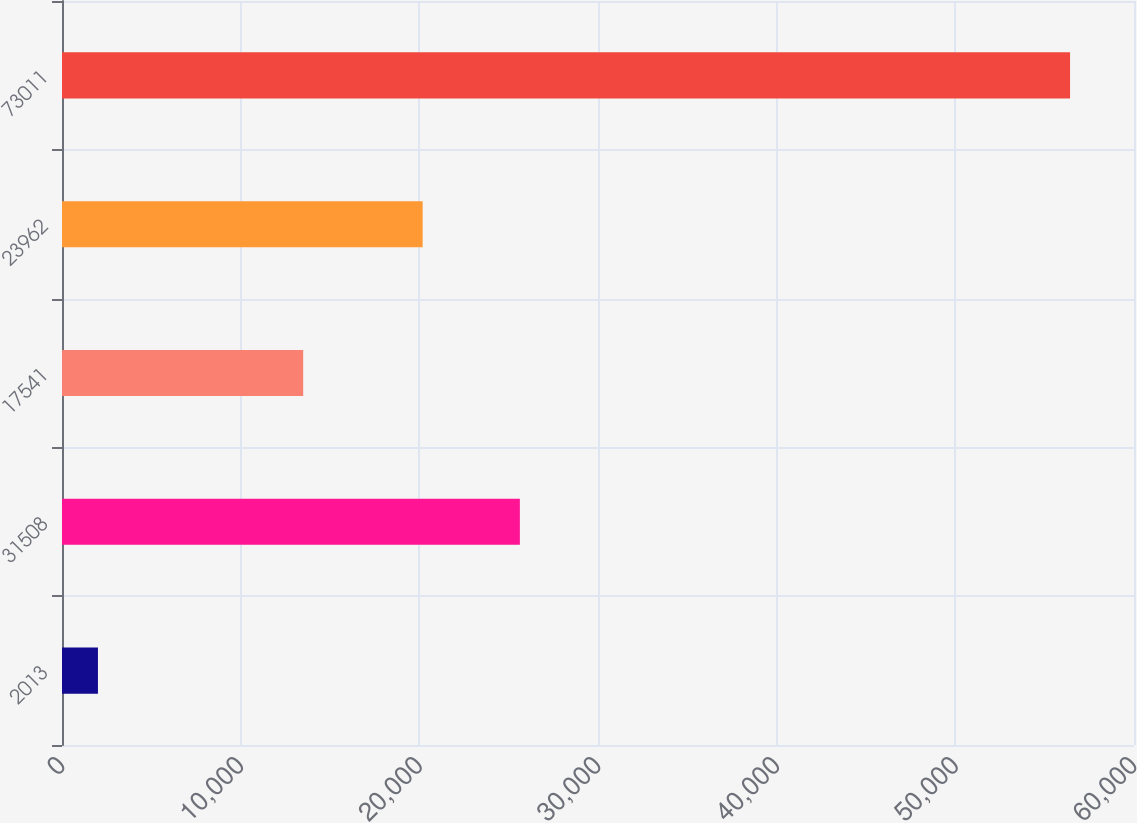Convert chart to OTSL. <chart><loc_0><loc_0><loc_500><loc_500><bar_chart><fcel>2013<fcel>31508<fcel>17541<fcel>23962<fcel>73011<nl><fcel>2012<fcel>25626.9<fcel>13499<fcel>20186<fcel>56421<nl></chart> 